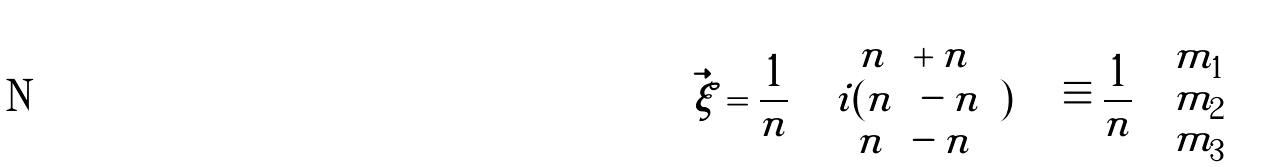Convert formula to latex. <formula><loc_0><loc_0><loc_500><loc_500>\vec { \xi } = \frac { 1 } { n } \left ( \begin{array} { c } n _ { \uparrow \downarrow } + n _ { \downarrow \uparrow } \\ i ( n _ { \uparrow \downarrow } - n _ { \downarrow \uparrow } ) \\ n _ { \uparrow \uparrow } - n _ { \downarrow \downarrow } \end{array} \right ) \equiv \frac { 1 } { n } \left ( \begin{array} { c } m _ { 1 } \\ m _ { 2 } \\ m _ { 3 } \end{array} \right )</formula> 